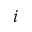<formula> <loc_0><loc_0><loc_500><loc_500>i</formula> 